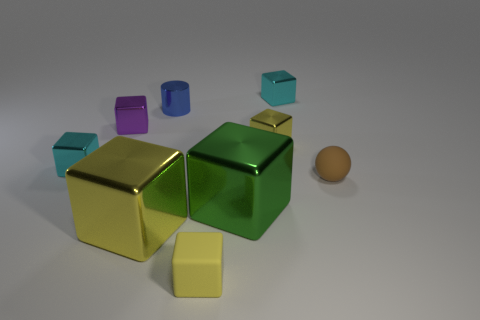Subtract all red cylinders. How many yellow cubes are left? 3 Subtract 1 cubes. How many cubes are left? 6 Subtract all yellow blocks. How many blocks are left? 4 Subtract all cyan shiny cubes. How many cubes are left? 5 Subtract all cyan cubes. Subtract all brown balls. How many cubes are left? 5 Add 1 tiny gray balls. How many objects exist? 10 Subtract all cylinders. How many objects are left? 8 Add 6 big metallic objects. How many big metallic objects are left? 8 Add 7 big cylinders. How many big cylinders exist? 7 Subtract 0 gray cylinders. How many objects are left? 9 